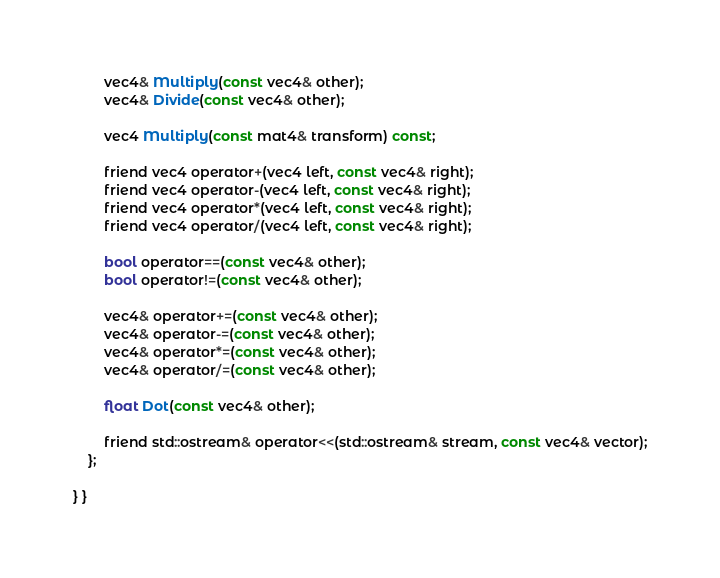<code> <loc_0><loc_0><loc_500><loc_500><_C_>        vec4& Multiply(const vec4& other);
        vec4& Divide(const vec4& other);

        vec4 Multiply(const mat4& transform) const;

        friend vec4 operator+(vec4 left, const vec4& right);
        friend vec4 operator-(vec4 left, const vec4& right);
        friend vec4 operator*(vec4 left, const vec4& right);
        friend vec4 operator/(vec4 left, const vec4& right);

        bool operator==(const vec4& other);
        bool operator!=(const vec4& other);

        vec4& operator+=(const vec4& other);
        vec4& operator-=(const vec4& other);
        vec4& operator*=(const vec4& other);
        vec4& operator/=(const vec4& other);

        float Dot(const vec4& other);

        friend std::ostream& operator<<(std::ostream& stream, const vec4& vector);
    };

} }</code> 